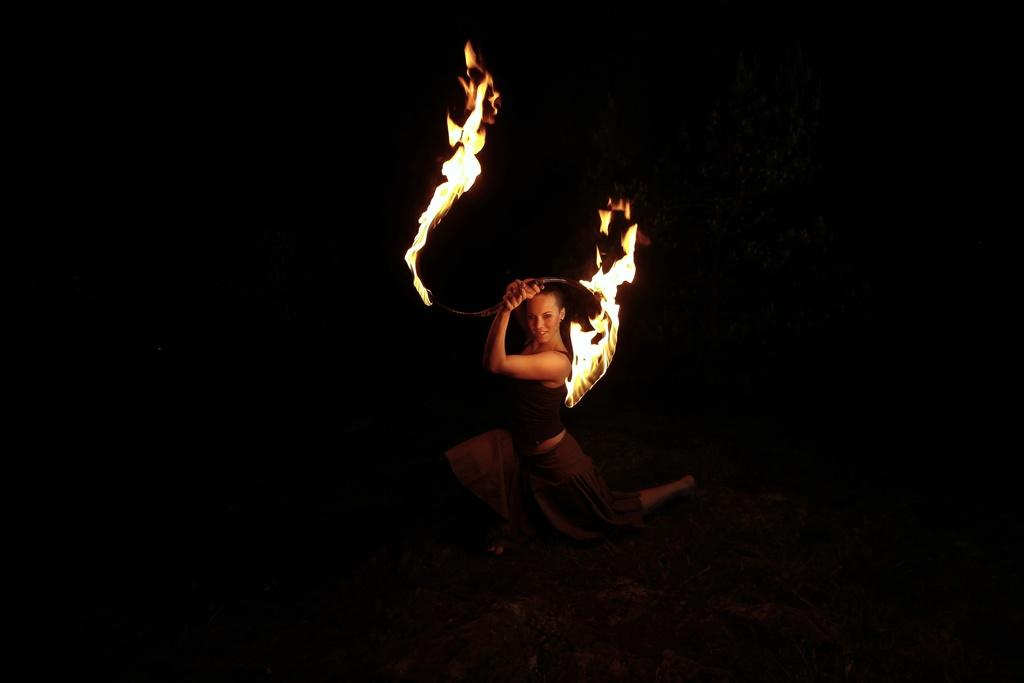Who is the main subject in the image? There is a woman in the center of the image. What is the woman holding in the image? The woman is holding a stick. What is the source of light in the image? There is fire in the image, which is likely the source of light. What is the color of the background in the image? The background of the image is black. What type of class is being taught in the image? There is no class present in the image; it features a woman holding a stick with fire in the background. Is there a church visible in the image? There is no church present in the image. 